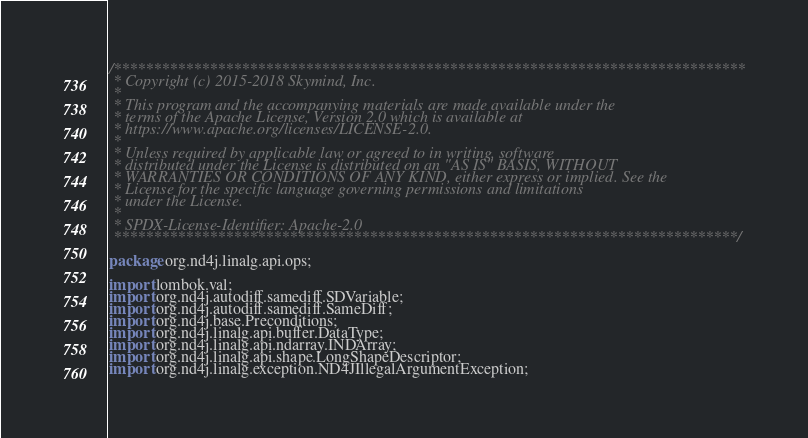Convert code to text. <code><loc_0><loc_0><loc_500><loc_500><_Java_>/*******************************************************************************
 * Copyright (c) 2015-2018 Skymind, Inc.
 *
 * This program and the accompanying materials are made available under the
 * terms of the Apache License, Version 2.0 which is available at
 * https://www.apache.org/licenses/LICENSE-2.0.
 *
 * Unless required by applicable law or agreed to in writing, software
 * distributed under the License is distributed on an "AS IS" BASIS, WITHOUT
 * WARRANTIES OR CONDITIONS OF ANY KIND, either express or implied. See the
 * License for the specific language governing permissions and limitations
 * under the License.
 *
 * SPDX-License-Identifier: Apache-2.0
 ******************************************************************************/

package org.nd4j.linalg.api.ops;

import lombok.val;
import org.nd4j.autodiff.samediff.SDVariable;
import org.nd4j.autodiff.samediff.SameDiff;
import org.nd4j.base.Preconditions;
import org.nd4j.linalg.api.buffer.DataType;
import org.nd4j.linalg.api.ndarray.INDArray;
import org.nd4j.linalg.api.shape.LongShapeDescriptor;
import org.nd4j.linalg.exception.ND4JIllegalArgumentException;</code> 